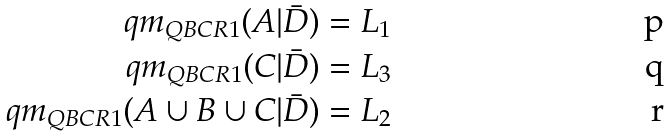Convert formula to latex. <formula><loc_0><loc_0><loc_500><loc_500>q m _ { Q B C R 1 } ( A | \bar { D } ) & = L _ { 1 } \\ q m _ { Q B C R 1 } ( C | \bar { D } ) & = L _ { 3 } \\ q m _ { Q B C R 1 } ( A \cup B \cup C | \bar { D } ) & = L _ { 2 }</formula> 